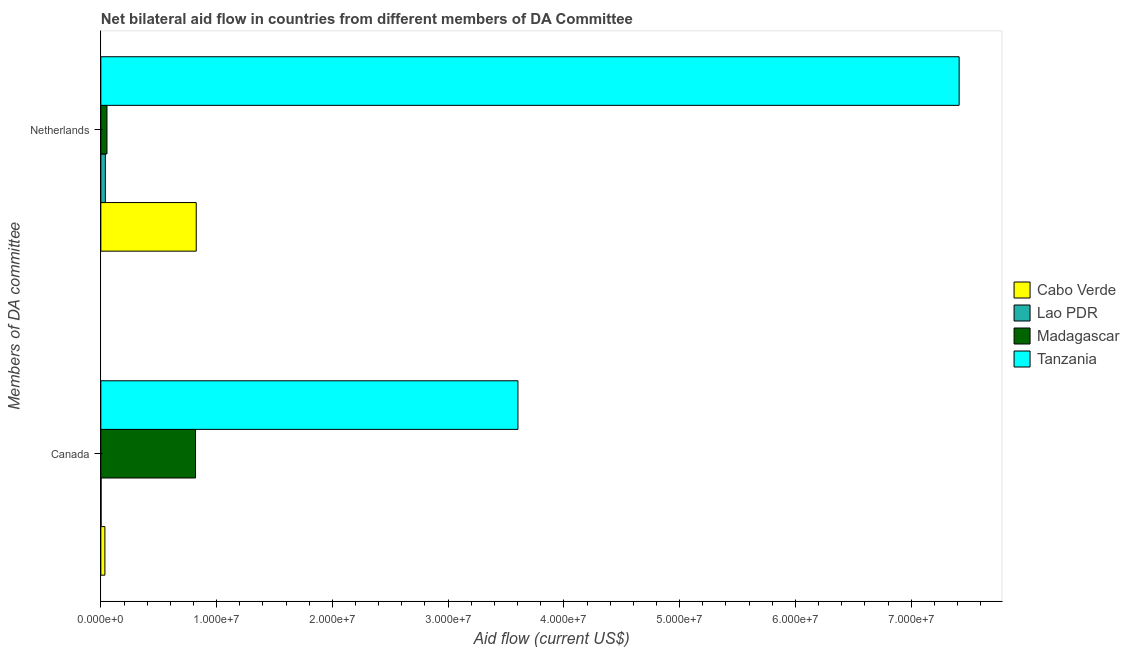How many groups of bars are there?
Provide a short and direct response. 2. Are the number of bars on each tick of the Y-axis equal?
Provide a succinct answer. Yes. What is the amount of aid given by netherlands in Lao PDR?
Ensure brevity in your answer.  3.90e+05. Across all countries, what is the maximum amount of aid given by netherlands?
Your response must be concise. 7.41e+07. Across all countries, what is the minimum amount of aid given by netherlands?
Keep it short and to the point. 3.90e+05. In which country was the amount of aid given by netherlands maximum?
Your answer should be very brief. Tanzania. In which country was the amount of aid given by canada minimum?
Your answer should be very brief. Lao PDR. What is the total amount of aid given by netherlands in the graph?
Your answer should be compact. 8.33e+07. What is the difference between the amount of aid given by canada in Lao PDR and that in Tanzania?
Give a very brief answer. -3.60e+07. What is the difference between the amount of aid given by netherlands in Lao PDR and the amount of aid given by canada in Madagascar?
Provide a succinct answer. -7.79e+06. What is the average amount of aid given by canada per country?
Offer a very short reply. 1.11e+07. What is the difference between the amount of aid given by netherlands and amount of aid given by canada in Tanzania?
Your response must be concise. 3.81e+07. In how many countries, is the amount of aid given by netherlands greater than 70000000 US$?
Your response must be concise. 1. What is the ratio of the amount of aid given by canada in Lao PDR to that in Cabo Verde?
Make the answer very short. 0.06. What does the 4th bar from the top in Netherlands represents?
Give a very brief answer. Cabo Verde. What does the 2nd bar from the bottom in Canada represents?
Your response must be concise. Lao PDR. How many bars are there?
Make the answer very short. 8. Are all the bars in the graph horizontal?
Provide a short and direct response. Yes. How many countries are there in the graph?
Provide a succinct answer. 4. What is the difference between two consecutive major ticks on the X-axis?
Offer a terse response. 1.00e+07. Does the graph contain any zero values?
Ensure brevity in your answer.  No. How many legend labels are there?
Offer a very short reply. 4. What is the title of the graph?
Provide a succinct answer. Net bilateral aid flow in countries from different members of DA Committee. Does "Guinea" appear as one of the legend labels in the graph?
Your answer should be compact. No. What is the label or title of the Y-axis?
Your response must be concise. Members of DA committee. What is the Aid flow (current US$) of Madagascar in Canada?
Provide a succinct answer. 8.18e+06. What is the Aid flow (current US$) of Tanzania in Canada?
Ensure brevity in your answer.  3.60e+07. What is the Aid flow (current US$) of Cabo Verde in Netherlands?
Offer a very short reply. 8.24e+06. What is the Aid flow (current US$) of Madagascar in Netherlands?
Offer a very short reply. 5.30e+05. What is the Aid flow (current US$) of Tanzania in Netherlands?
Give a very brief answer. 7.41e+07. Across all Members of DA committee, what is the maximum Aid flow (current US$) in Cabo Verde?
Your answer should be compact. 8.24e+06. Across all Members of DA committee, what is the maximum Aid flow (current US$) of Lao PDR?
Your response must be concise. 3.90e+05. Across all Members of DA committee, what is the maximum Aid flow (current US$) in Madagascar?
Make the answer very short. 8.18e+06. Across all Members of DA committee, what is the maximum Aid flow (current US$) in Tanzania?
Your answer should be very brief. 7.41e+07. Across all Members of DA committee, what is the minimum Aid flow (current US$) of Cabo Verde?
Ensure brevity in your answer.  3.50e+05. Across all Members of DA committee, what is the minimum Aid flow (current US$) in Lao PDR?
Offer a very short reply. 2.00e+04. Across all Members of DA committee, what is the minimum Aid flow (current US$) in Madagascar?
Your answer should be very brief. 5.30e+05. Across all Members of DA committee, what is the minimum Aid flow (current US$) in Tanzania?
Offer a terse response. 3.60e+07. What is the total Aid flow (current US$) in Cabo Verde in the graph?
Provide a succinct answer. 8.59e+06. What is the total Aid flow (current US$) in Lao PDR in the graph?
Your answer should be very brief. 4.10e+05. What is the total Aid flow (current US$) of Madagascar in the graph?
Your response must be concise. 8.71e+06. What is the total Aid flow (current US$) of Tanzania in the graph?
Provide a short and direct response. 1.10e+08. What is the difference between the Aid flow (current US$) of Cabo Verde in Canada and that in Netherlands?
Provide a short and direct response. -7.89e+06. What is the difference between the Aid flow (current US$) in Lao PDR in Canada and that in Netherlands?
Keep it short and to the point. -3.70e+05. What is the difference between the Aid flow (current US$) in Madagascar in Canada and that in Netherlands?
Your answer should be very brief. 7.65e+06. What is the difference between the Aid flow (current US$) of Tanzania in Canada and that in Netherlands?
Your response must be concise. -3.81e+07. What is the difference between the Aid flow (current US$) in Cabo Verde in Canada and the Aid flow (current US$) in Tanzania in Netherlands?
Offer a very short reply. -7.38e+07. What is the difference between the Aid flow (current US$) of Lao PDR in Canada and the Aid flow (current US$) of Madagascar in Netherlands?
Provide a short and direct response. -5.10e+05. What is the difference between the Aid flow (current US$) in Lao PDR in Canada and the Aid flow (current US$) in Tanzania in Netherlands?
Offer a very short reply. -7.41e+07. What is the difference between the Aid flow (current US$) of Madagascar in Canada and the Aid flow (current US$) of Tanzania in Netherlands?
Your answer should be compact. -6.60e+07. What is the average Aid flow (current US$) of Cabo Verde per Members of DA committee?
Make the answer very short. 4.30e+06. What is the average Aid flow (current US$) of Lao PDR per Members of DA committee?
Your answer should be compact. 2.05e+05. What is the average Aid flow (current US$) in Madagascar per Members of DA committee?
Offer a very short reply. 4.36e+06. What is the average Aid flow (current US$) in Tanzania per Members of DA committee?
Give a very brief answer. 5.51e+07. What is the difference between the Aid flow (current US$) in Cabo Verde and Aid flow (current US$) in Madagascar in Canada?
Make the answer very short. -7.83e+06. What is the difference between the Aid flow (current US$) in Cabo Verde and Aid flow (current US$) in Tanzania in Canada?
Offer a very short reply. -3.57e+07. What is the difference between the Aid flow (current US$) in Lao PDR and Aid flow (current US$) in Madagascar in Canada?
Ensure brevity in your answer.  -8.16e+06. What is the difference between the Aid flow (current US$) in Lao PDR and Aid flow (current US$) in Tanzania in Canada?
Your answer should be very brief. -3.60e+07. What is the difference between the Aid flow (current US$) of Madagascar and Aid flow (current US$) of Tanzania in Canada?
Your response must be concise. -2.78e+07. What is the difference between the Aid flow (current US$) of Cabo Verde and Aid flow (current US$) of Lao PDR in Netherlands?
Offer a very short reply. 7.85e+06. What is the difference between the Aid flow (current US$) of Cabo Verde and Aid flow (current US$) of Madagascar in Netherlands?
Your answer should be very brief. 7.71e+06. What is the difference between the Aid flow (current US$) in Cabo Verde and Aid flow (current US$) in Tanzania in Netherlands?
Your answer should be compact. -6.59e+07. What is the difference between the Aid flow (current US$) of Lao PDR and Aid flow (current US$) of Tanzania in Netherlands?
Your response must be concise. -7.38e+07. What is the difference between the Aid flow (current US$) in Madagascar and Aid flow (current US$) in Tanzania in Netherlands?
Offer a terse response. -7.36e+07. What is the ratio of the Aid flow (current US$) in Cabo Verde in Canada to that in Netherlands?
Provide a succinct answer. 0.04. What is the ratio of the Aid flow (current US$) in Lao PDR in Canada to that in Netherlands?
Offer a very short reply. 0.05. What is the ratio of the Aid flow (current US$) in Madagascar in Canada to that in Netherlands?
Make the answer very short. 15.43. What is the ratio of the Aid flow (current US$) of Tanzania in Canada to that in Netherlands?
Keep it short and to the point. 0.49. What is the difference between the highest and the second highest Aid flow (current US$) of Cabo Verde?
Provide a short and direct response. 7.89e+06. What is the difference between the highest and the second highest Aid flow (current US$) of Lao PDR?
Give a very brief answer. 3.70e+05. What is the difference between the highest and the second highest Aid flow (current US$) of Madagascar?
Give a very brief answer. 7.65e+06. What is the difference between the highest and the second highest Aid flow (current US$) of Tanzania?
Ensure brevity in your answer.  3.81e+07. What is the difference between the highest and the lowest Aid flow (current US$) in Cabo Verde?
Give a very brief answer. 7.89e+06. What is the difference between the highest and the lowest Aid flow (current US$) in Lao PDR?
Your response must be concise. 3.70e+05. What is the difference between the highest and the lowest Aid flow (current US$) in Madagascar?
Keep it short and to the point. 7.65e+06. What is the difference between the highest and the lowest Aid flow (current US$) in Tanzania?
Provide a succinct answer. 3.81e+07. 